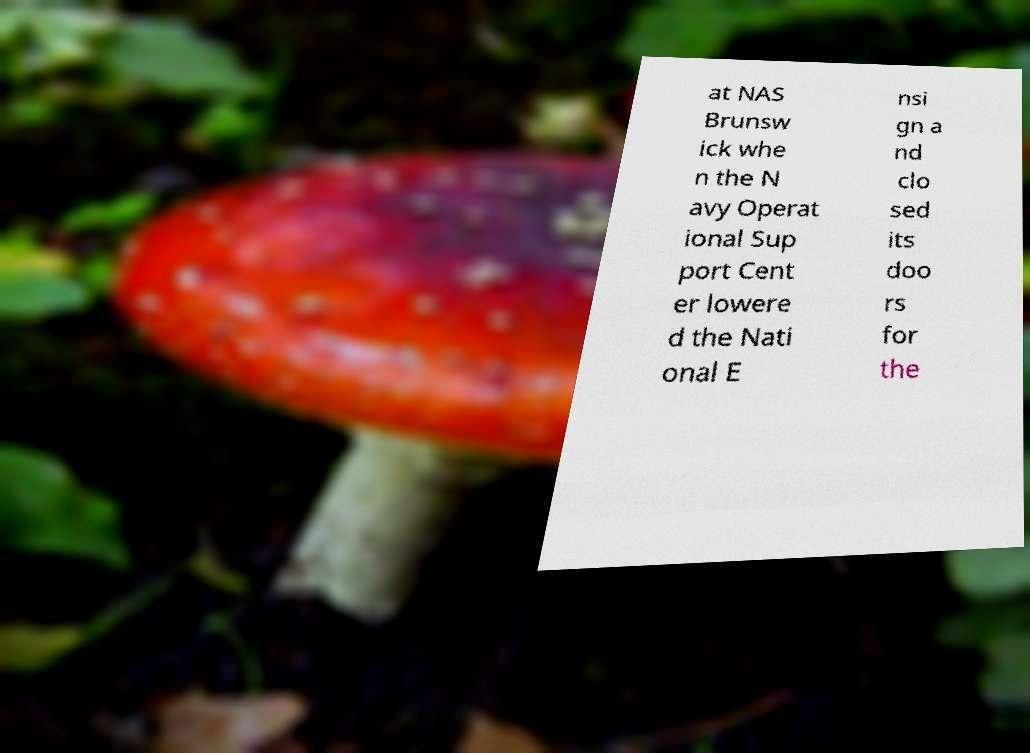Please identify and transcribe the text found in this image. at NAS Brunsw ick whe n the N avy Operat ional Sup port Cent er lowere d the Nati onal E nsi gn a nd clo sed its doo rs for the 